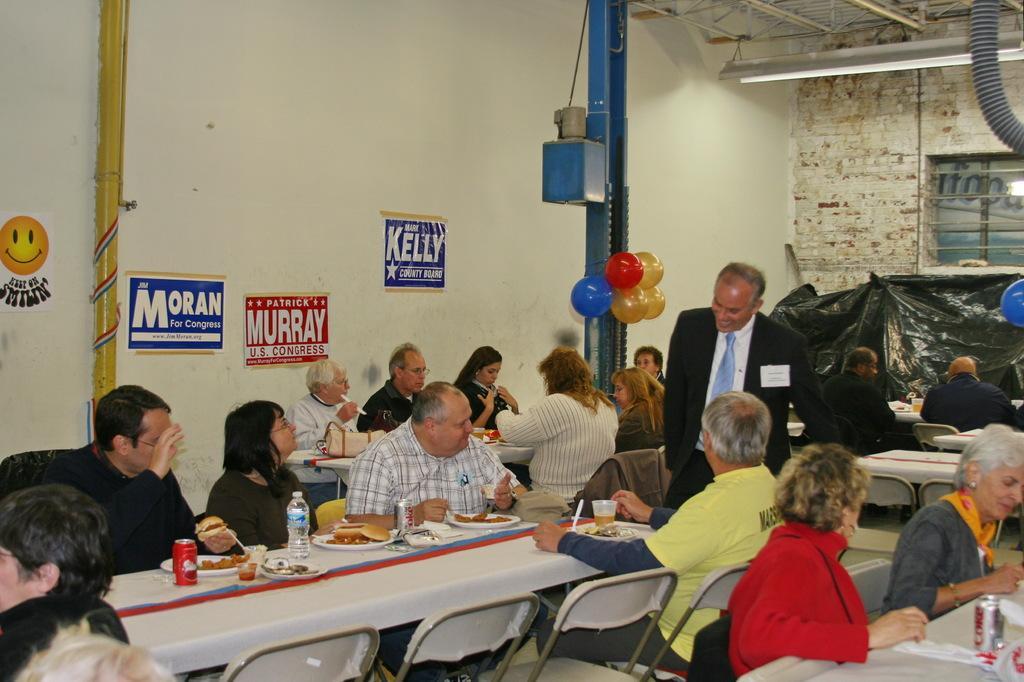Describe this image in one or two sentences. In the image in the center we can see one man standing,around him we can see group of were sitting on the chair around the table. On table we can see some food items. And back there is a wall,pole,smile emoji,pipe and light etc. 